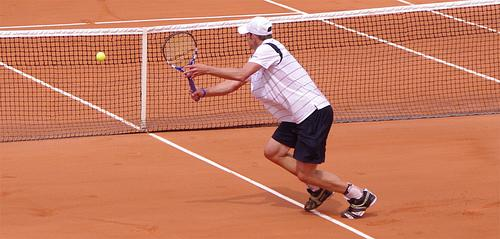Briefly describe the appearance and position of the tennis net in the image. The tennis net is long, low to the ground, and positioned in the middle of the court. List the colors of the items worn or used by the man playing tennis. The man is wearing a white hat, a striped shirt, navy blue shorts, white and black tennis shoes, and a blue rubber bracelet, and he's using a blue and white tennis racket. Create a short advertisement for the tennis shoes seen in the image. Introducing our new athletic footwear, perfect for tennis players looking for style and performance! These white and blue tennis shoes offer supreme comfort, support, and traction on any court surface. Get yours now! Describe the color of the man's shirt and the pattern it has. The man is wearing a white polo shirt with thin black stripes. Explain the position and appearance of the tennis ball during the action captured in the image. The tennis ball is neon yellow and in mid-air during the man's swing, away from the court's surface. Identify the main action performed by the person in the image and describe the object they are using. The man in the image is playing tennis, hitting a ball with a blue and white tennis racket. Answer the following question: What type of tennis court is depicted in the image? The image shows a red clay tennis court. Using the details given, describe the appearance of the tennis court. The tennis court is made of red clay with white lines marking boundaries, and has a long and low net in the middle. Which specific details describe the tennis player's attire and accessories? The tennis player is wearing a white hat with small panels, a white polo shirt with thin black stripes, black polynylon shorts, a blue rubber bracelet on his right wrist, white and black tennis shoes, and he has a blue and white tennis racket. Select a referential phrase describing the tennis ball's position and appearance. Yellow tennis ball in mid air. 